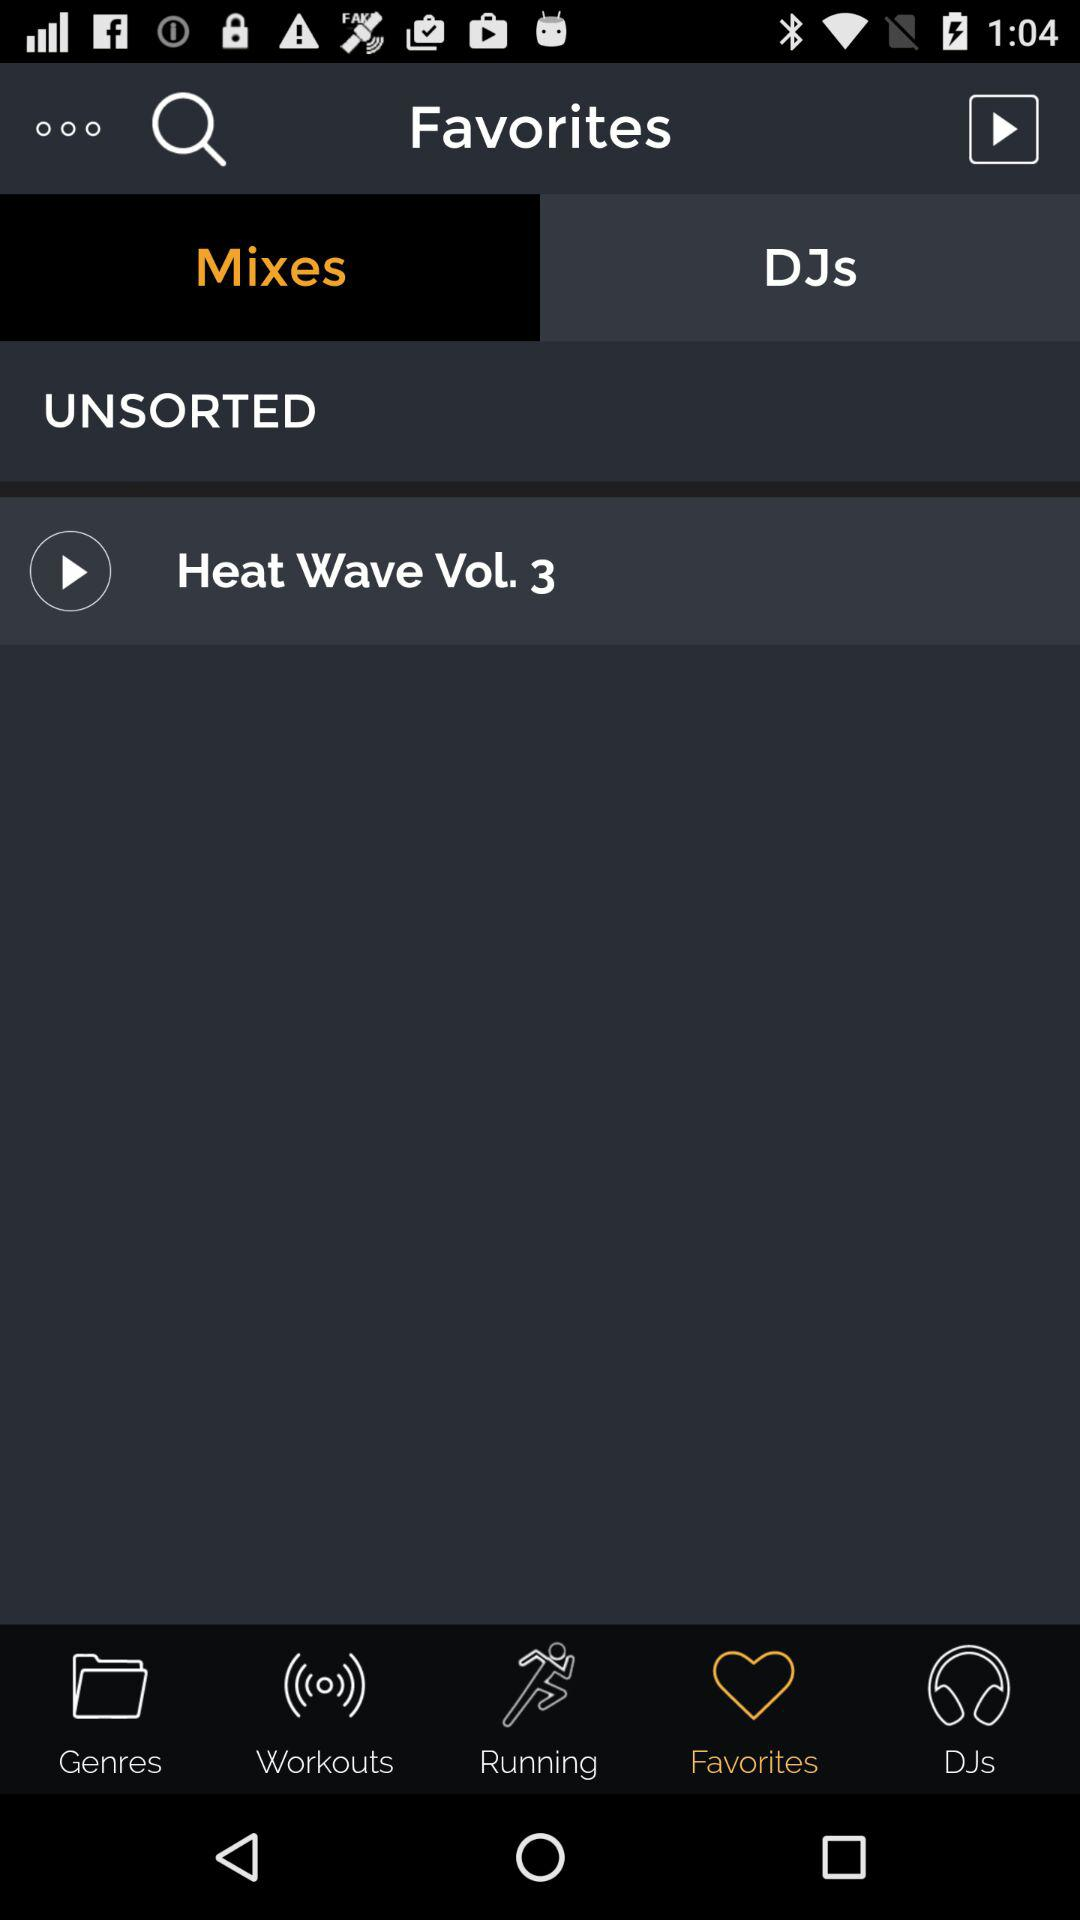What song is in the favorites list? The song "Heat Wave Vol. 3" is in the favorites list. 